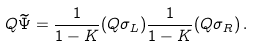Convert formula to latex. <formula><loc_0><loc_0><loc_500><loc_500>Q \widetilde { \Psi } = \frac { 1 } { 1 - K } ( Q \sigma _ { L } ) \frac { 1 } { 1 - K } ( Q \sigma _ { R } ) \, .</formula> 